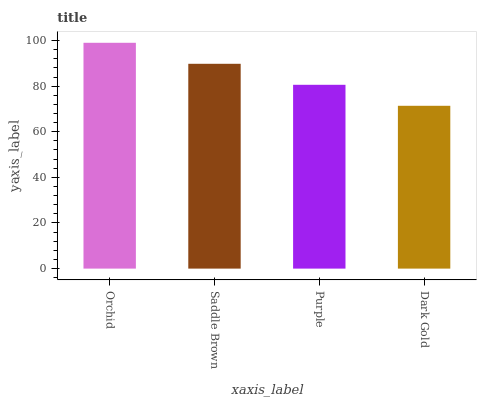Is Dark Gold the minimum?
Answer yes or no. Yes. Is Orchid the maximum?
Answer yes or no. Yes. Is Saddle Brown the minimum?
Answer yes or no. No. Is Saddle Brown the maximum?
Answer yes or no. No. Is Orchid greater than Saddle Brown?
Answer yes or no. Yes. Is Saddle Brown less than Orchid?
Answer yes or no. Yes. Is Saddle Brown greater than Orchid?
Answer yes or no. No. Is Orchid less than Saddle Brown?
Answer yes or no. No. Is Saddle Brown the high median?
Answer yes or no. Yes. Is Purple the low median?
Answer yes or no. Yes. Is Orchid the high median?
Answer yes or no. No. Is Dark Gold the low median?
Answer yes or no. No. 